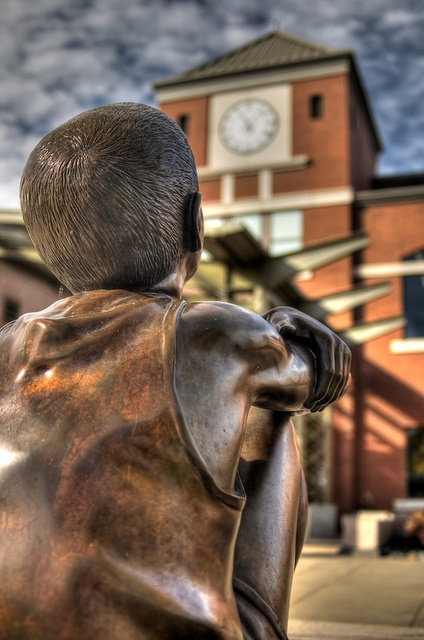Describe the objects in this image and their specific colors. I can see people in gray, maroon, and black tones and clock in gray, darkgray, tan, and lightgray tones in this image. 